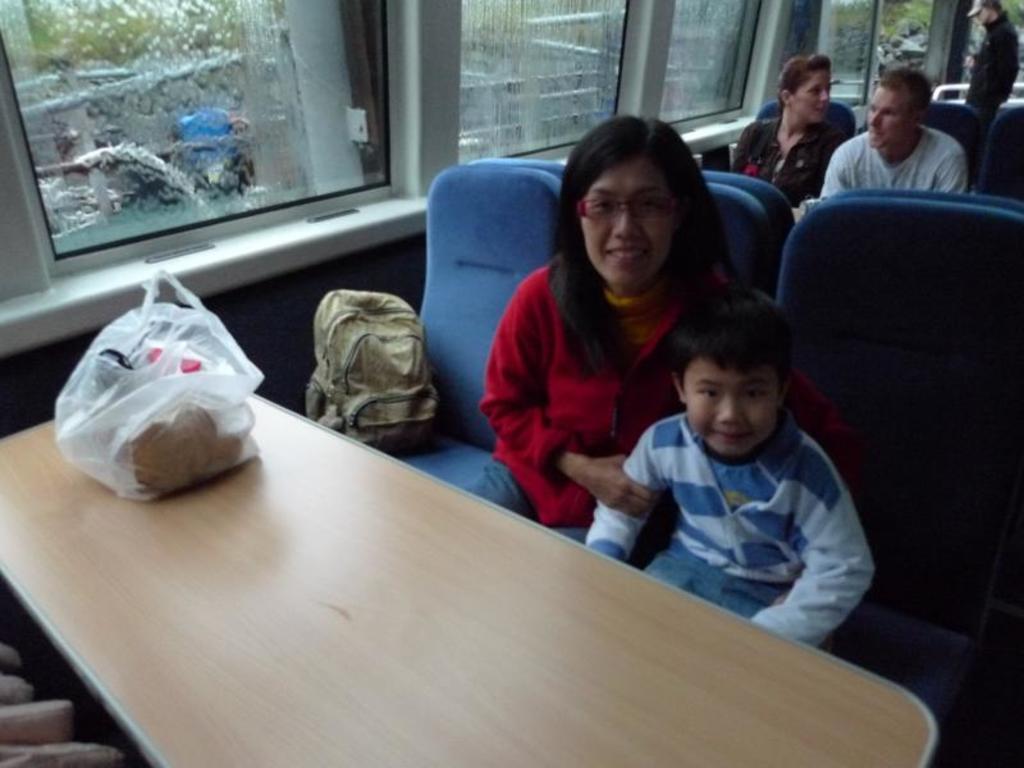In one or two sentences, can you explain what this image depicts? In this image, There is a table which is in yellow color on that there is a carry bag which is in white color, In the right side of the image there are some chairs which are in blue color, There is a woman and a boy sitting on the chairs, In the background there is a glass window which is in white color. 